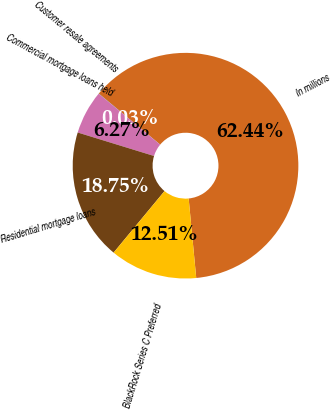<chart> <loc_0><loc_0><loc_500><loc_500><pie_chart><fcel>In millions<fcel>Customer resale agreements<fcel>Commercial mortgage loans held<fcel>Residential mortgage loans<fcel>BlackRock Series C Preferred<nl><fcel>62.43%<fcel>0.03%<fcel>6.27%<fcel>18.75%<fcel>12.51%<nl></chart> 